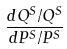Convert formula to latex. <formula><loc_0><loc_0><loc_500><loc_500>\frac { d Q ^ { S } / Q ^ { S } } { d P ^ { S } / P ^ { S } }</formula> 